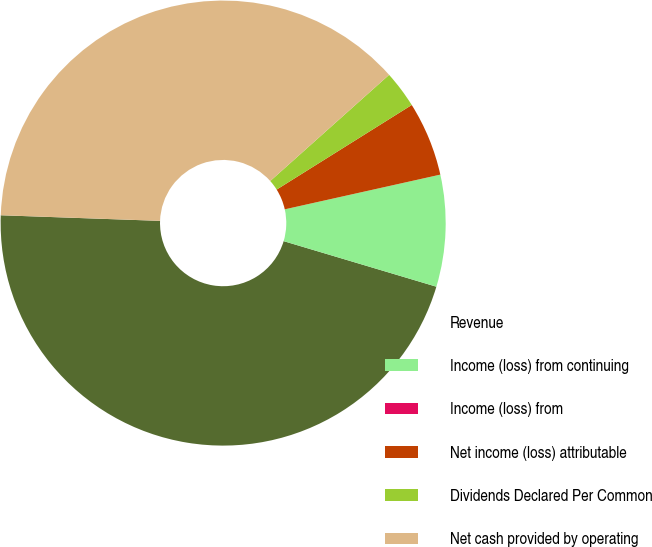Convert chart to OTSL. <chart><loc_0><loc_0><loc_500><loc_500><pie_chart><fcel>Revenue<fcel>Income (loss) from continuing<fcel>Income (loss) from<fcel>Net income (loss) attributable<fcel>Dividends Declared Per Common<fcel>Net cash provided by operating<nl><fcel>45.95%<fcel>8.11%<fcel>0.0%<fcel>5.41%<fcel>2.7%<fcel>37.84%<nl></chart> 